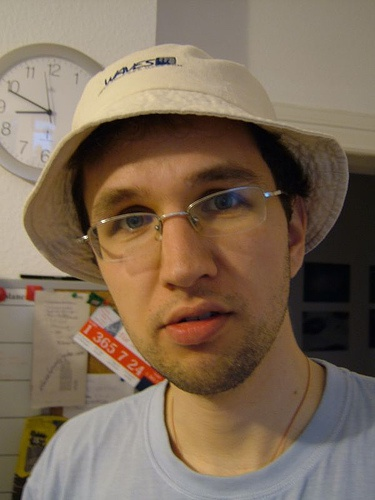Describe the objects in this image and their specific colors. I can see people in darkgray, maroon, and black tones and clock in darkgray, tan, and gray tones in this image. 